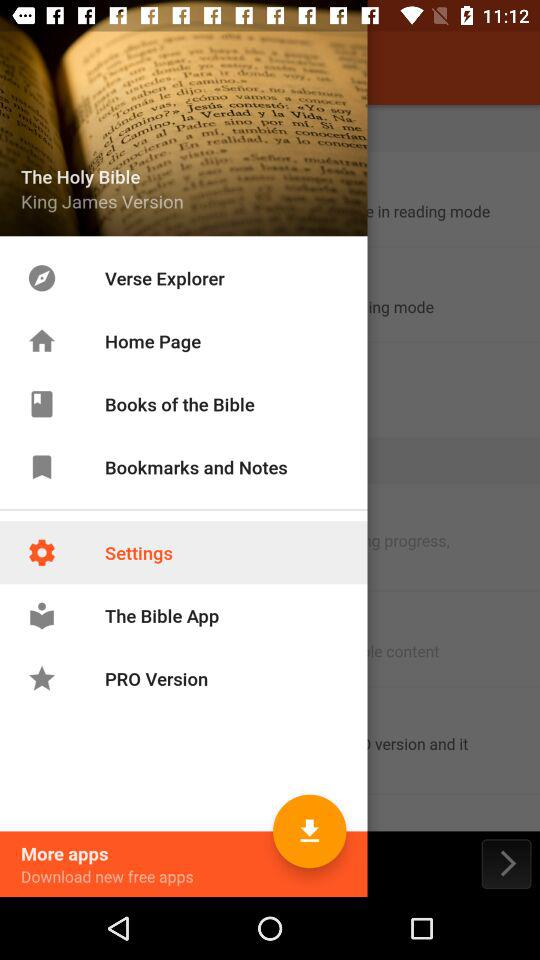What type of version is mentioned? The type of version is "King James". 